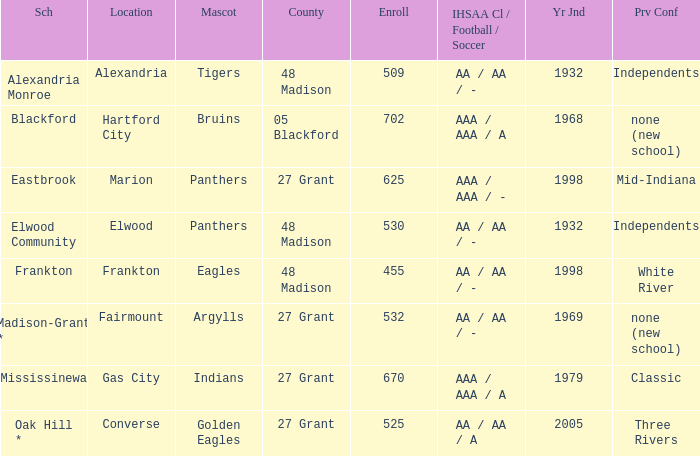What is teh ihsaa class/football/soccer when the location is alexandria? AA / AA / -. 